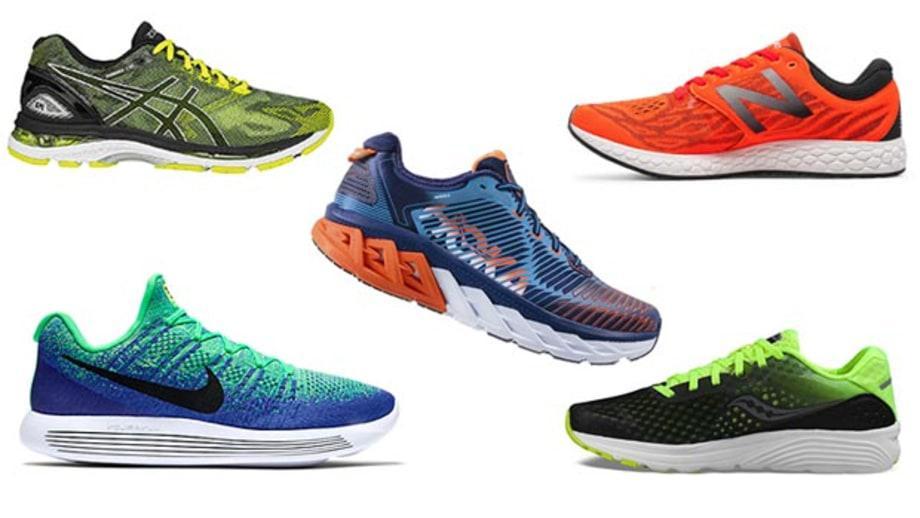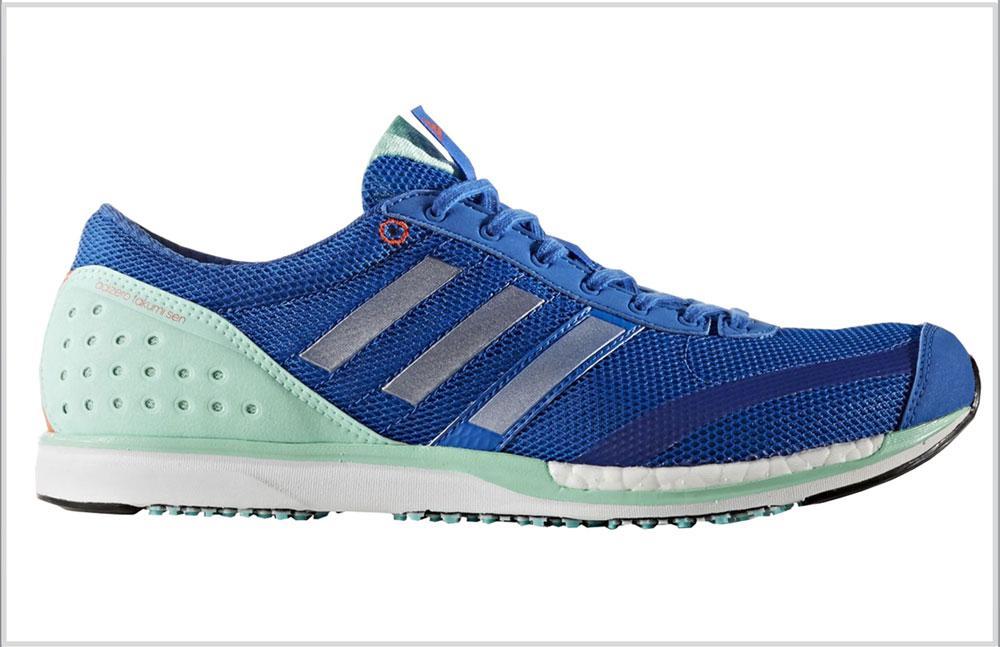The first image is the image on the left, the second image is the image on the right. For the images shown, is this caption "There is a pair of matching shoes in at least one of the images." true? Answer yes or no. No. The first image is the image on the left, the second image is the image on the right. Analyze the images presented: Is the assertion "No more than four sneakers are shown in total, and one sneaker is shown heel-first." valid? Answer yes or no. No. 